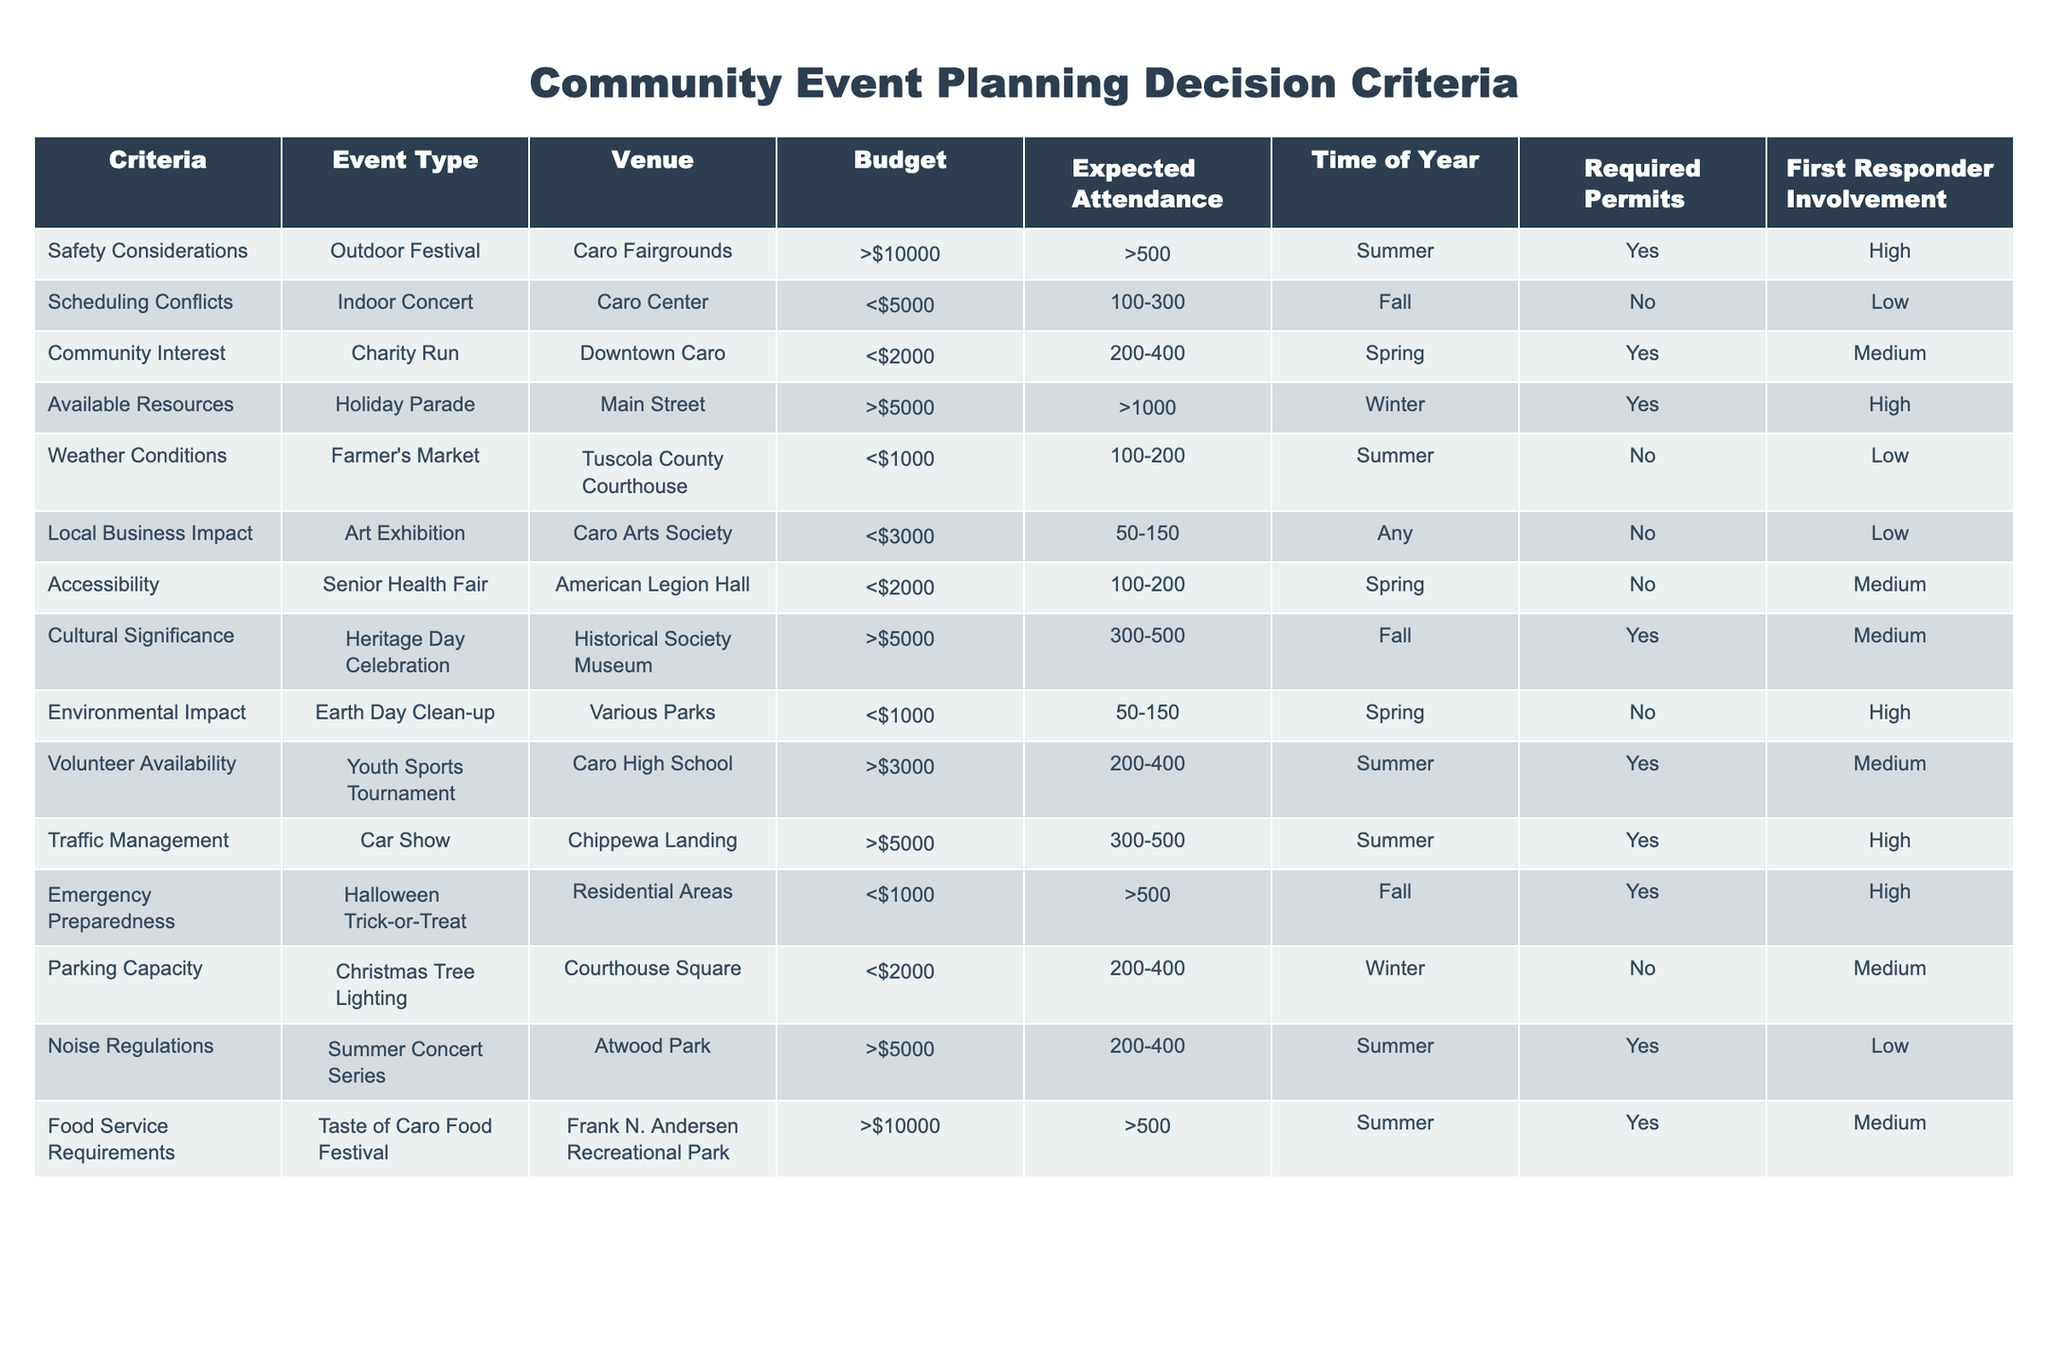What is the expected attendance for the Charity Run? The table indicates that the expected attendance for the Charity Run is between 200 and 400 people. This can be found in the "Expected Attendance" column corresponding to the "Charity Run" event type.
Answer: 200-400 Which event type requires a permit? By examining the "Required Permits" column, I see that the "Outdoor Festival," "Charity Run," "Holiday Parade," "Heritage Day Celebration," "Halloween Trick-or-Treat," and "Youth Sports Tournament" require permits.
Answer: Outdoor Festival, Charity Run, Holiday Parade, Heritage Day Celebration, Halloween Trick-or-Treat, Youth Sports Tournament Are most events held in the summer? To determine this, I can check the "Time of Year" column for all events. The events listed under summer are the "Outdoor Festival," "Farmer's Market," "Youth Sports Tournament," "Traffic Management," "Food Service Requirements," which totals 5 out of 12 events, while those in Fall, Spring, and Winter are fewer. Thus, more events are in summer than any other season.
Answer: Yes What is the total number of events that require high first responder involvement? In the "First Responder Involvement" column, the events with high involvement are the "Outdoor Festival," "Holiday Parade," "Traffic Management," and "Halloween Trick-or-Treat," totaling 4 events. The calculation involves counting the entries under this classification.
Answer: 4 What is the average expected attendance for events that occur in the Spring? The events in Spring are the "Charity Run," "Senior Health Fair," and "Earth Day Clean-up." Their expected attendances are 200-400 (average 300), 100-200 (average 150), and 50-150 (average 100). To find the average, I calculate (300 + 150 + 100) / 3 = 550 / 3 = approximately 183.33.
Answer: 183.33 